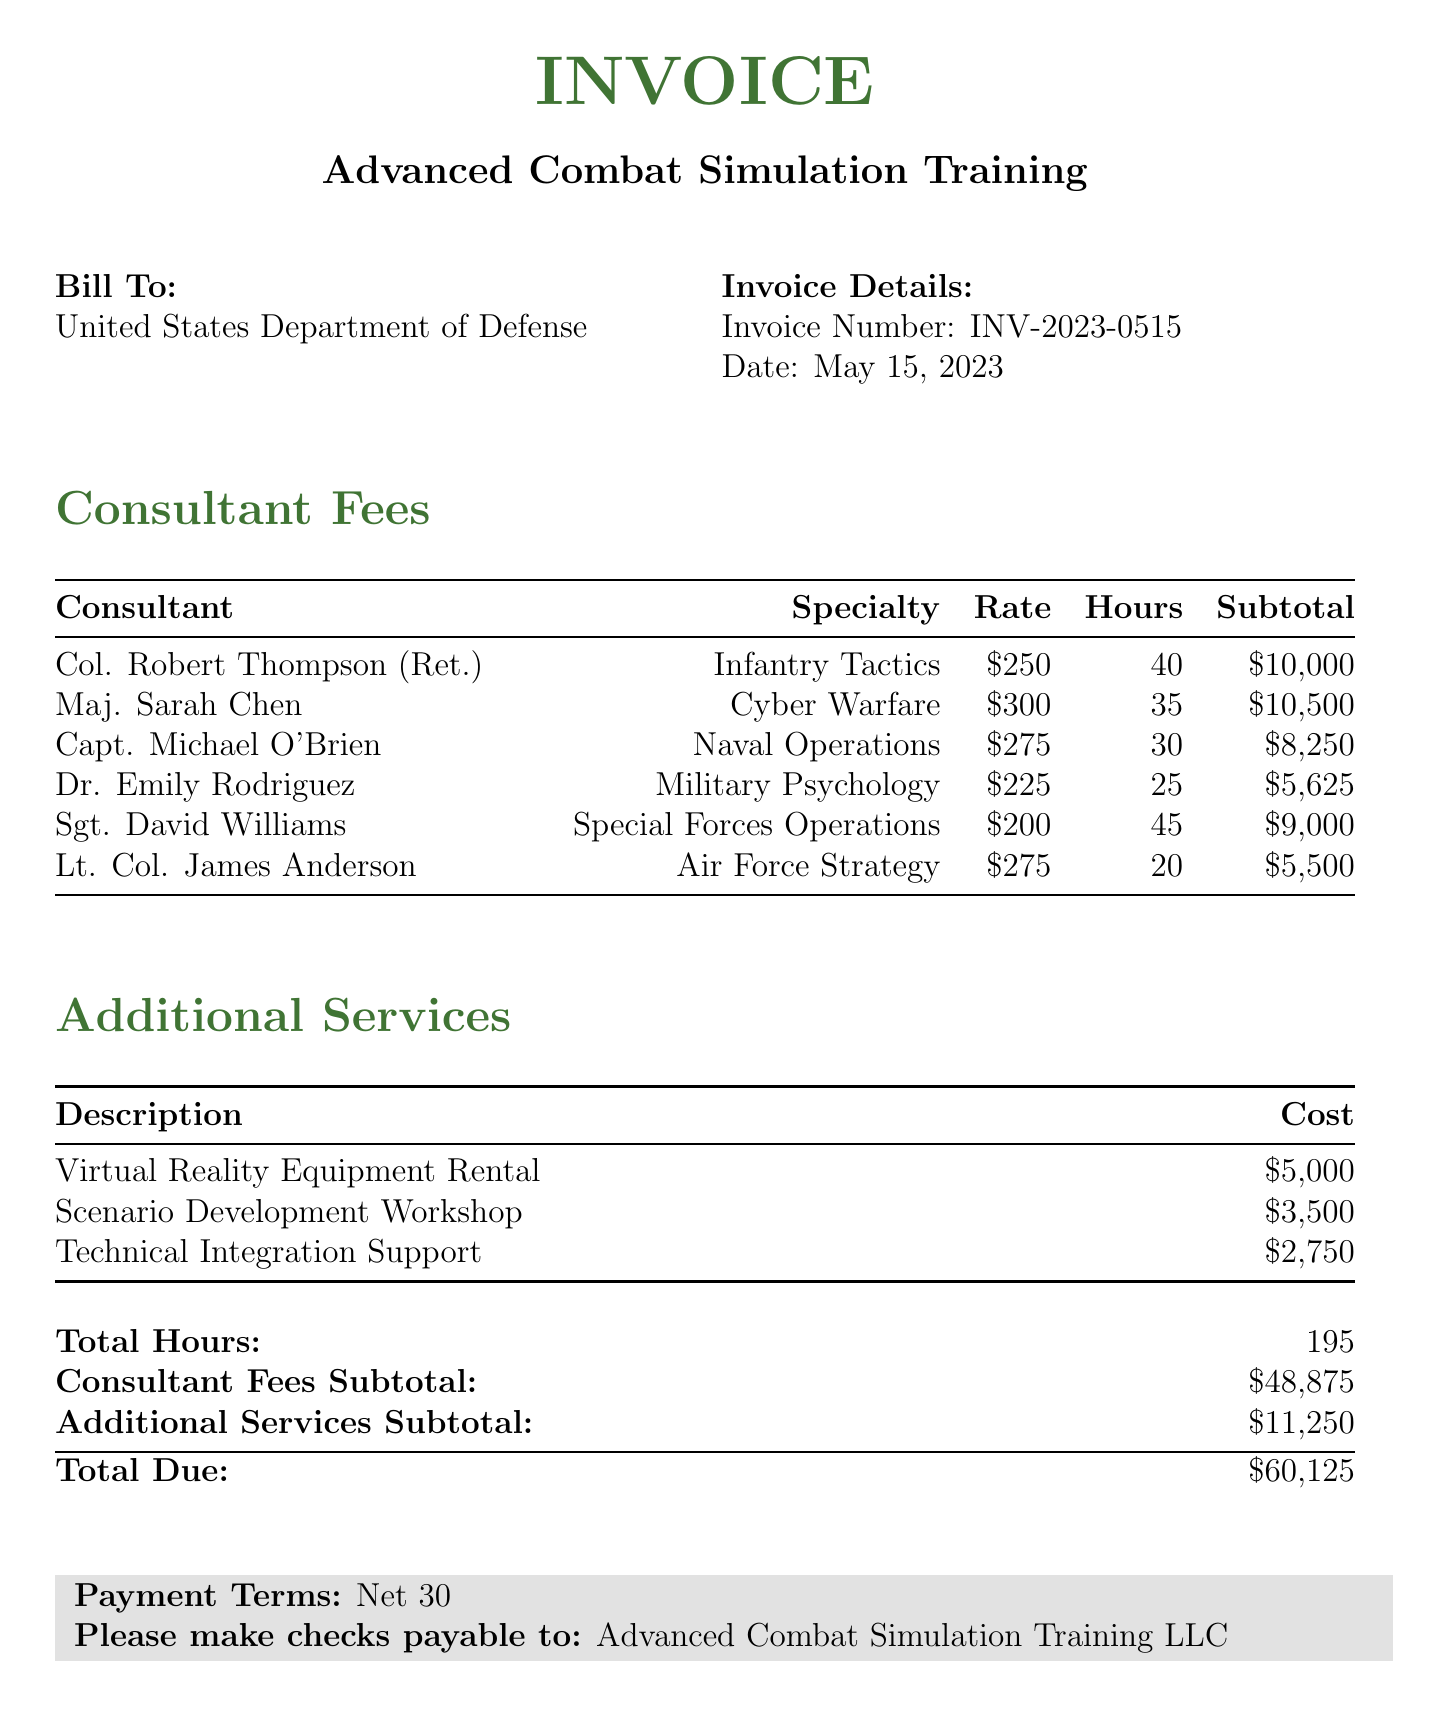What is the name of the client? The client name mentioned in the document is "United States Department of Defense."
Answer: United States Department of Defense What is the invoice date? The invoice date is provided in the document as May 15, 2023.
Answer: May 15, 2023 How many hours did Capt. Michael O'Brien work? The document shows that Capt. Michael O'Brien worked a total of 30 hours.
Answer: 30 What is the specialty of Maj. Sarah Chen? The specialty associated with Maj. Sarah Chen listed in the invoice is "Cyber Warfare."
Answer: Cyber Warfare What is the subtotal for consultant fees? The subtotal for the consultant fees is clearly stated as $48,875 in the document.
Answer: $48,875 What is the total amount due on the invoice? The total amount due for the invoice is mentioned as $60,125.
Answer: $60,125 Which additional service costs $5,000? The document lists "Virtual Reality Equipment Rental" as the additional service costing $5,000.
Answer: Virtual Reality Equipment Rental How many total consultants are listed? The document lists a total of 6 consultants providing their services.
Answer: 6 What is the payment term specified in the invoice? The payment term specified is "Net 30."
Answer: Net 30 